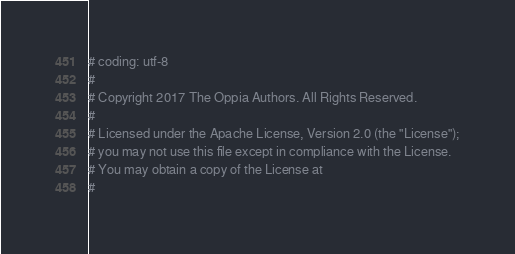<code> <loc_0><loc_0><loc_500><loc_500><_Python_># coding: utf-8
#
# Copyright 2017 The Oppia Authors. All Rights Reserved.
#
# Licensed under the Apache License, Version 2.0 (the "License");
# you may not use this file except in compliance with the License.
# You may obtain a copy of the License at
#</code> 